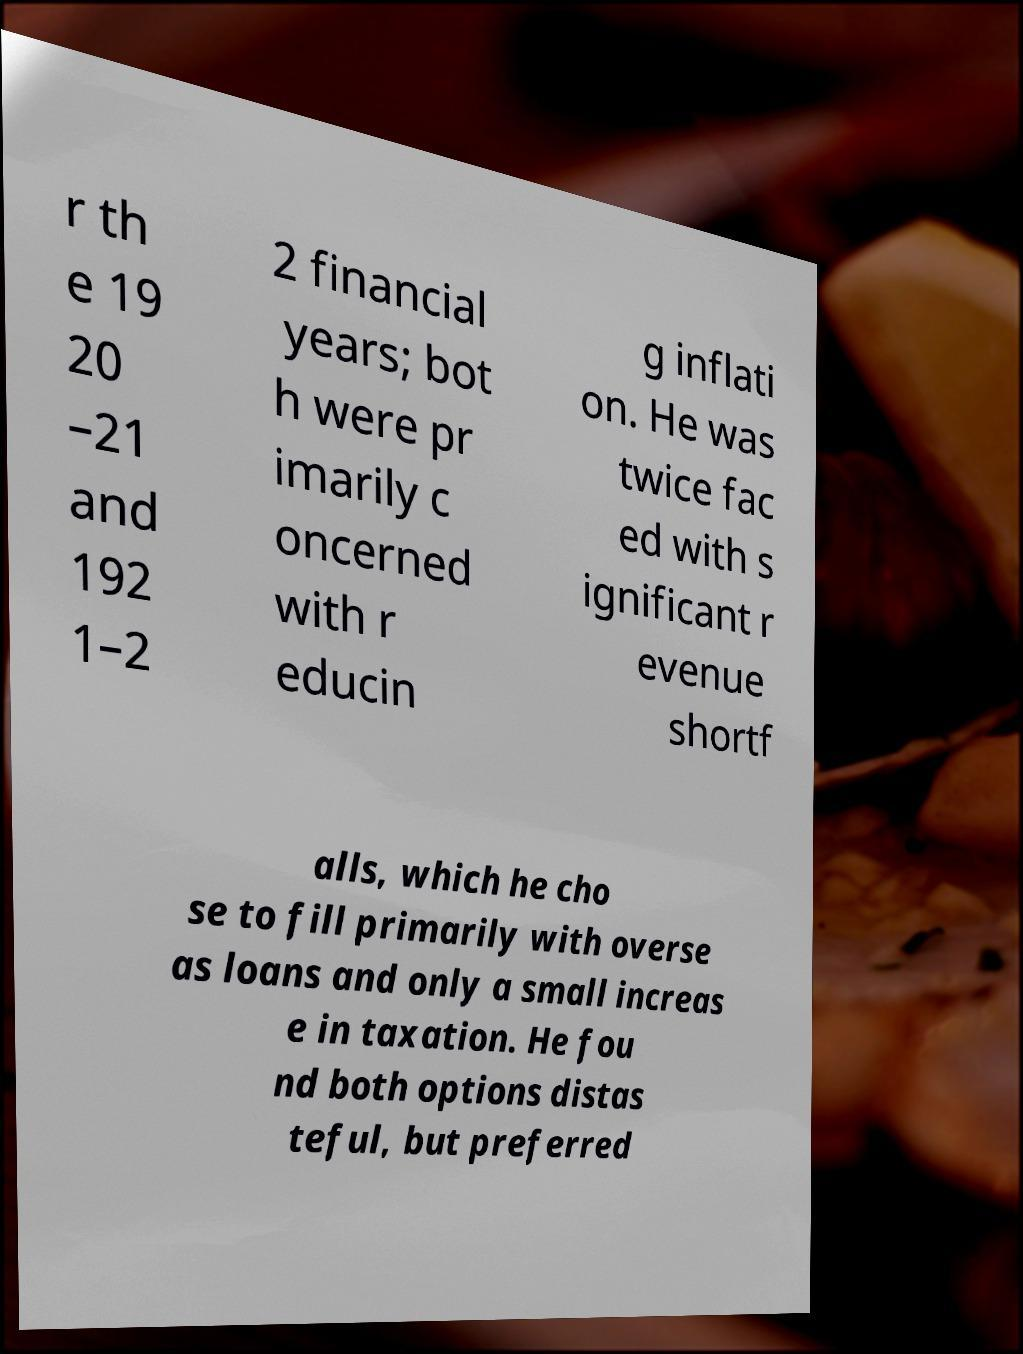Can you accurately transcribe the text from the provided image for me? r th e 19 20 –21 and 192 1–2 2 financial years; bot h were pr imarily c oncerned with r educin g inflati on. He was twice fac ed with s ignificant r evenue shortf alls, which he cho se to fill primarily with overse as loans and only a small increas e in taxation. He fou nd both options distas teful, but preferred 